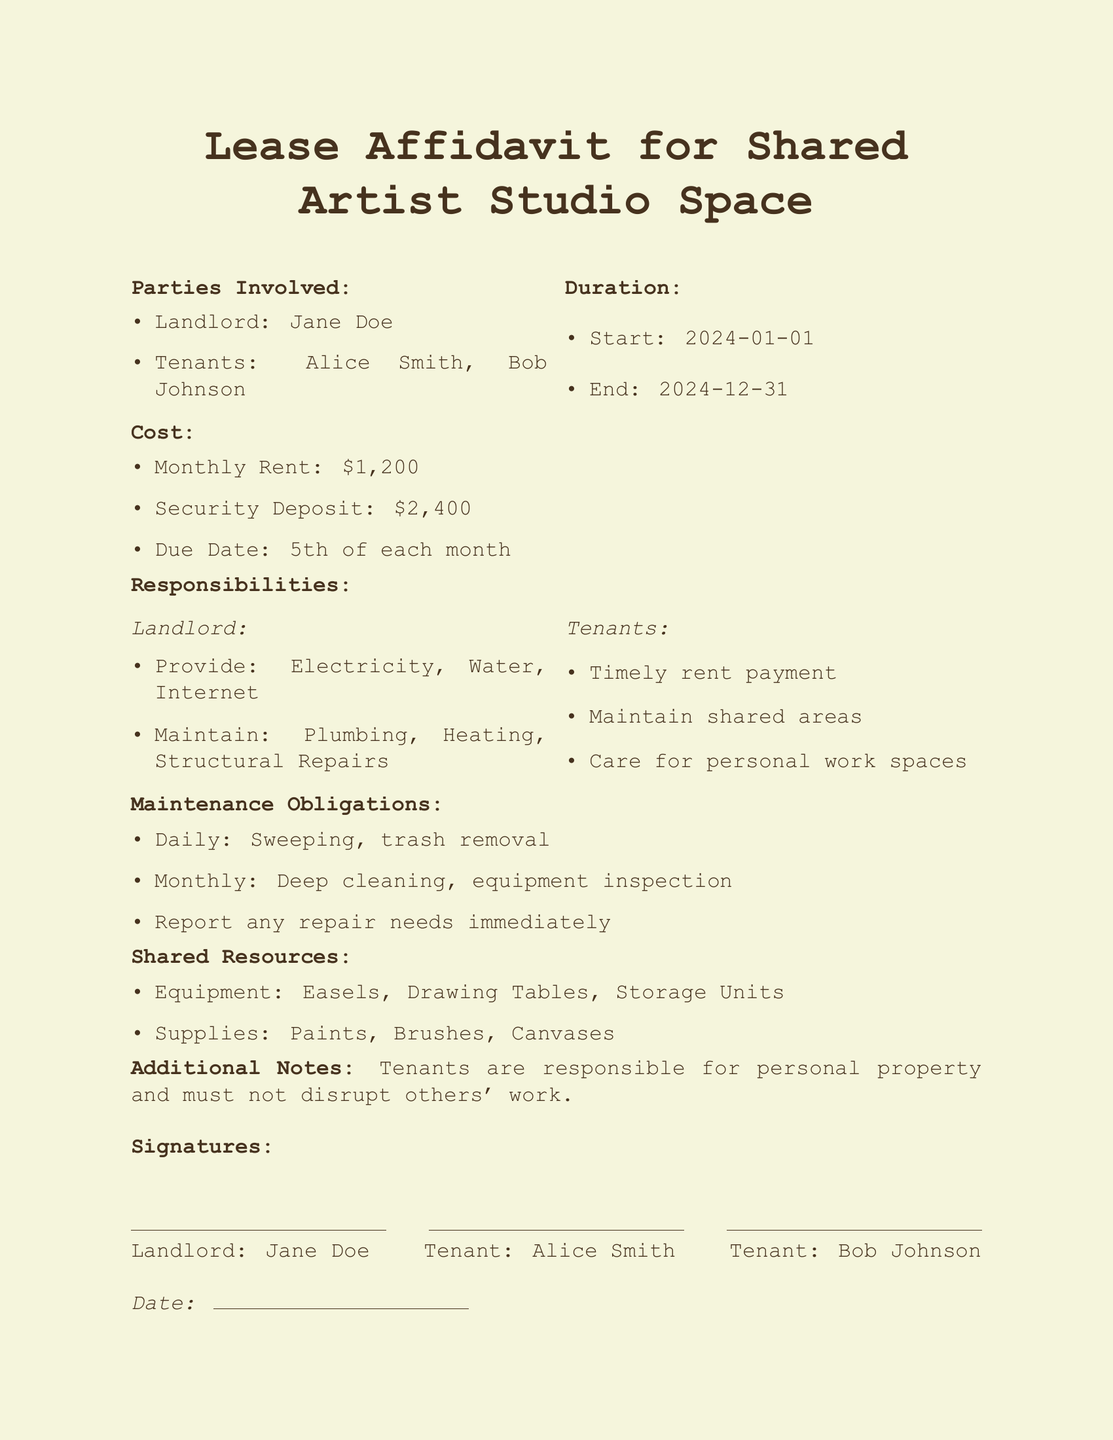What is the name of the landlord? The landlord's name is listed in the document under "Parties Involved."
Answer: Jane Doe What is the duration of the lease? The duration is specified with start and end dates.
Answer: From 2024-01-01 to 2024-12-31 What is the monthly rent? The monthly rent is detailed under the "Cost" section of the document.
Answer: $1,200 How much is the security deposit? The security deposit is provided in the "Cost" section.
Answer: $2,400 What is one responsibility of the landlord? Responsibilities of the landlord are outlined, and at least one example is given.
Answer: Provide: Electricity What are tenants required to maintain? The document specifies what tenants are responsible for in the "Responsibilities" section.
Answer: Shared areas When is the rent due each month? The due date is mentioned under the "Cost" section of the document.
Answer: 5th of each month What maintenance is required daily? The "Maintenance Obligations" section lists tasks that need to be done daily.
Answer: Sweeping What shared resources are mentioned? The document specifies shared resources in a dedicated section.
Answer: Equipment: Easels What must tenants do regarding their personal property? An additional note in the document clarifies tenant obligations regarding personal property.
Answer: Responsible for personal property 